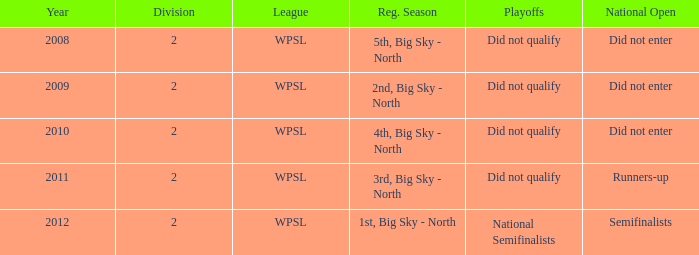During the 2009 regular season, what was it called when they didn't secure a spot in the playoffs? 2nd, Big Sky - North. 